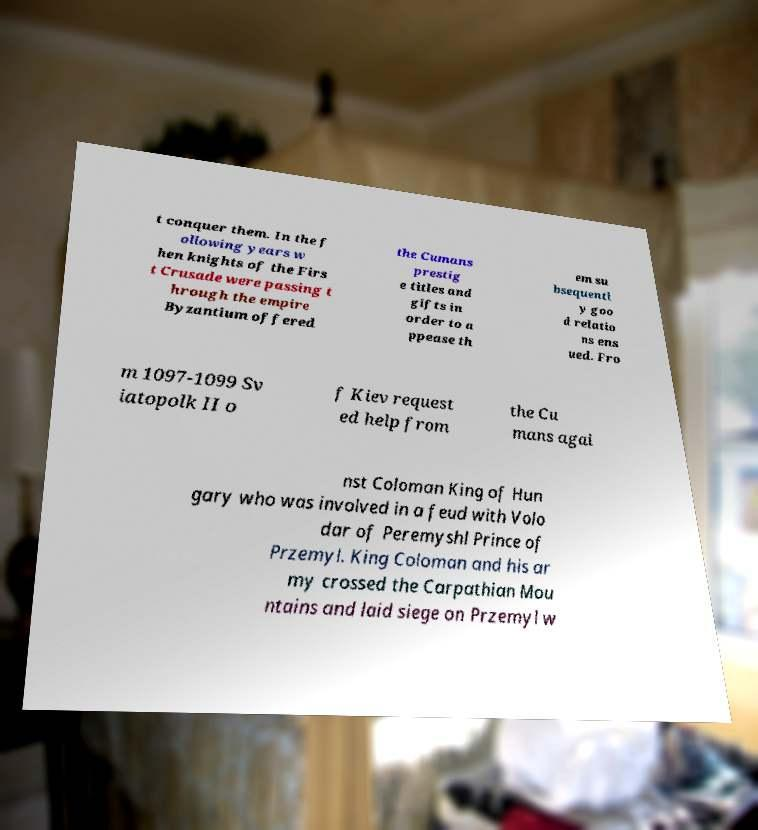Can you accurately transcribe the text from the provided image for me? t conquer them. In the f ollowing years w hen knights of the Firs t Crusade were passing t hrough the empire Byzantium offered the Cumans prestig e titles and gifts in order to a ppease th em su bsequentl y goo d relatio ns ens ued. Fro m 1097-1099 Sv iatopolk II o f Kiev request ed help from the Cu mans agai nst Coloman King of Hun gary who was involved in a feud with Volo dar of Peremyshl Prince of Przemyl. King Coloman and his ar my crossed the Carpathian Mou ntains and laid siege on Przemyl w 